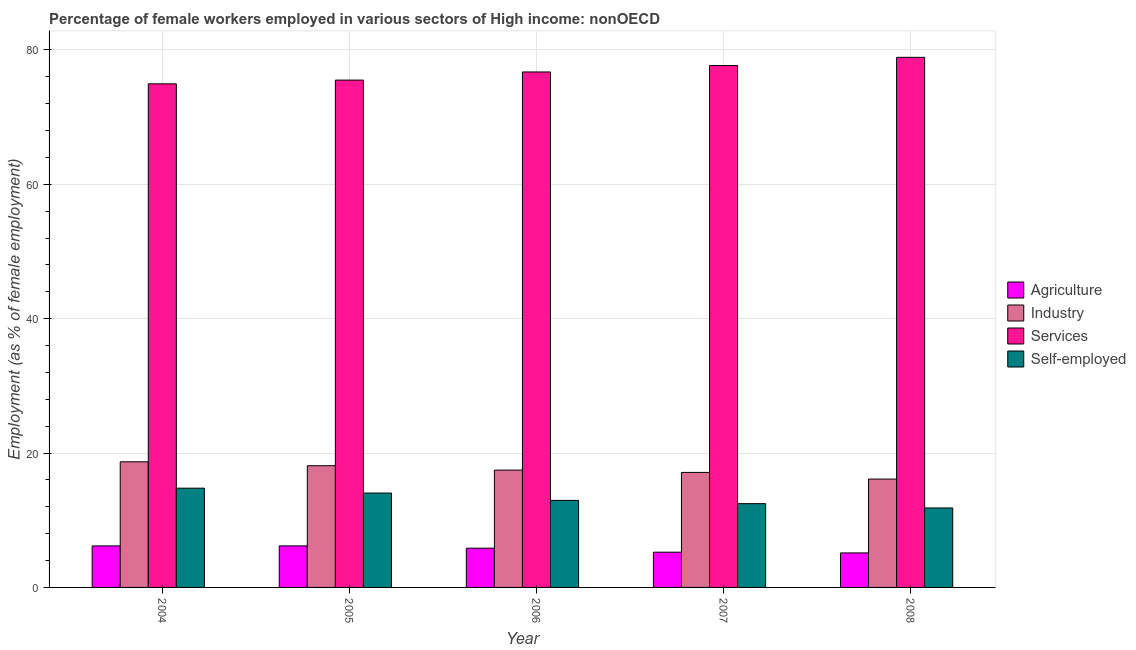How many different coloured bars are there?
Give a very brief answer. 4. In how many cases, is the number of bars for a given year not equal to the number of legend labels?
Give a very brief answer. 0. What is the percentage of female workers in agriculture in 2008?
Your answer should be very brief. 5.14. Across all years, what is the maximum percentage of female workers in agriculture?
Offer a very short reply. 6.18. Across all years, what is the minimum percentage of female workers in services?
Provide a short and direct response. 74.95. In which year was the percentage of female workers in services minimum?
Give a very brief answer. 2004. What is the total percentage of female workers in industry in the graph?
Give a very brief answer. 87.52. What is the difference between the percentage of female workers in industry in 2005 and that in 2007?
Offer a terse response. 1. What is the difference between the percentage of self employed female workers in 2005 and the percentage of female workers in services in 2007?
Ensure brevity in your answer.  1.58. What is the average percentage of self employed female workers per year?
Your response must be concise. 13.21. In how many years, is the percentage of female workers in industry greater than 32 %?
Your answer should be compact. 0. What is the ratio of the percentage of female workers in industry in 2006 to that in 2008?
Make the answer very short. 1.08. What is the difference between the highest and the second highest percentage of female workers in industry?
Your response must be concise. 0.58. What is the difference between the highest and the lowest percentage of female workers in agriculture?
Ensure brevity in your answer.  1.05. In how many years, is the percentage of female workers in services greater than the average percentage of female workers in services taken over all years?
Offer a very short reply. 2. Is the sum of the percentage of female workers in industry in 2007 and 2008 greater than the maximum percentage of female workers in agriculture across all years?
Provide a succinct answer. Yes. Is it the case that in every year, the sum of the percentage of female workers in agriculture and percentage of female workers in services is greater than the sum of percentage of female workers in industry and percentage of self employed female workers?
Make the answer very short. No. What does the 3rd bar from the left in 2004 represents?
Your answer should be compact. Services. What does the 3rd bar from the right in 2005 represents?
Give a very brief answer. Industry. How many bars are there?
Offer a very short reply. 20. How many years are there in the graph?
Offer a terse response. 5. Are the values on the major ticks of Y-axis written in scientific E-notation?
Ensure brevity in your answer.  No. Does the graph contain any zero values?
Your response must be concise. No. What is the title of the graph?
Keep it short and to the point. Percentage of female workers employed in various sectors of High income: nonOECD. What is the label or title of the X-axis?
Ensure brevity in your answer.  Year. What is the label or title of the Y-axis?
Your response must be concise. Employment (as % of female employment). What is the Employment (as % of female employment) in Agriculture in 2004?
Your answer should be compact. 6.18. What is the Employment (as % of female employment) of Industry in 2004?
Your answer should be very brief. 18.7. What is the Employment (as % of female employment) of Services in 2004?
Your answer should be very brief. 74.95. What is the Employment (as % of female employment) of Self-employed in 2004?
Give a very brief answer. 14.77. What is the Employment (as % of female employment) of Agriculture in 2005?
Make the answer very short. 6.18. What is the Employment (as % of female employment) in Industry in 2005?
Offer a very short reply. 18.11. What is the Employment (as % of female employment) of Services in 2005?
Offer a terse response. 75.51. What is the Employment (as % of female employment) in Self-employed in 2005?
Keep it short and to the point. 14.05. What is the Employment (as % of female employment) in Agriculture in 2006?
Offer a very short reply. 5.84. What is the Employment (as % of female employment) in Industry in 2006?
Offer a very short reply. 17.46. What is the Employment (as % of female employment) in Services in 2006?
Ensure brevity in your answer.  76.72. What is the Employment (as % of female employment) of Self-employed in 2006?
Your answer should be compact. 12.95. What is the Employment (as % of female employment) in Agriculture in 2007?
Your response must be concise. 5.24. What is the Employment (as % of female employment) of Industry in 2007?
Ensure brevity in your answer.  17.12. What is the Employment (as % of female employment) in Services in 2007?
Provide a succinct answer. 77.68. What is the Employment (as % of female employment) in Self-employed in 2007?
Offer a very short reply. 12.47. What is the Employment (as % of female employment) in Agriculture in 2008?
Offer a terse response. 5.14. What is the Employment (as % of female employment) of Industry in 2008?
Provide a short and direct response. 16.13. What is the Employment (as % of female employment) in Services in 2008?
Give a very brief answer. 78.9. What is the Employment (as % of female employment) in Self-employed in 2008?
Provide a short and direct response. 11.83. Across all years, what is the maximum Employment (as % of female employment) of Agriculture?
Provide a succinct answer. 6.18. Across all years, what is the maximum Employment (as % of female employment) of Industry?
Make the answer very short. 18.7. Across all years, what is the maximum Employment (as % of female employment) in Services?
Keep it short and to the point. 78.9. Across all years, what is the maximum Employment (as % of female employment) in Self-employed?
Your answer should be very brief. 14.77. Across all years, what is the minimum Employment (as % of female employment) of Agriculture?
Offer a terse response. 5.14. Across all years, what is the minimum Employment (as % of female employment) of Industry?
Make the answer very short. 16.13. Across all years, what is the minimum Employment (as % of female employment) in Services?
Your response must be concise. 74.95. Across all years, what is the minimum Employment (as % of female employment) in Self-employed?
Your answer should be very brief. 11.83. What is the total Employment (as % of female employment) in Agriculture in the graph?
Your response must be concise. 28.58. What is the total Employment (as % of female employment) of Industry in the graph?
Offer a terse response. 87.52. What is the total Employment (as % of female employment) of Services in the graph?
Provide a succinct answer. 383.76. What is the total Employment (as % of female employment) of Self-employed in the graph?
Provide a short and direct response. 66.06. What is the difference between the Employment (as % of female employment) in Agriculture in 2004 and that in 2005?
Ensure brevity in your answer.  -0.01. What is the difference between the Employment (as % of female employment) of Industry in 2004 and that in 2005?
Your answer should be very brief. 0.58. What is the difference between the Employment (as % of female employment) of Services in 2004 and that in 2005?
Ensure brevity in your answer.  -0.56. What is the difference between the Employment (as % of female employment) in Self-employed in 2004 and that in 2005?
Offer a terse response. 0.72. What is the difference between the Employment (as % of female employment) of Agriculture in 2004 and that in 2006?
Keep it short and to the point. 0.34. What is the difference between the Employment (as % of female employment) in Industry in 2004 and that in 2006?
Provide a succinct answer. 1.23. What is the difference between the Employment (as % of female employment) in Services in 2004 and that in 2006?
Give a very brief answer. -1.77. What is the difference between the Employment (as % of female employment) in Self-employed in 2004 and that in 2006?
Your response must be concise. 1.82. What is the difference between the Employment (as % of female employment) in Agriculture in 2004 and that in 2007?
Your response must be concise. 0.93. What is the difference between the Employment (as % of female employment) of Industry in 2004 and that in 2007?
Your response must be concise. 1.58. What is the difference between the Employment (as % of female employment) in Services in 2004 and that in 2007?
Give a very brief answer. -2.72. What is the difference between the Employment (as % of female employment) in Self-employed in 2004 and that in 2007?
Your answer should be very brief. 2.3. What is the difference between the Employment (as % of female employment) in Agriculture in 2004 and that in 2008?
Ensure brevity in your answer.  1.04. What is the difference between the Employment (as % of female employment) of Industry in 2004 and that in 2008?
Make the answer very short. 2.57. What is the difference between the Employment (as % of female employment) of Services in 2004 and that in 2008?
Keep it short and to the point. -3.94. What is the difference between the Employment (as % of female employment) of Self-employed in 2004 and that in 2008?
Offer a terse response. 2.94. What is the difference between the Employment (as % of female employment) in Agriculture in 2005 and that in 2006?
Make the answer very short. 0.34. What is the difference between the Employment (as % of female employment) of Industry in 2005 and that in 2006?
Provide a short and direct response. 0.65. What is the difference between the Employment (as % of female employment) of Services in 2005 and that in 2006?
Give a very brief answer. -1.21. What is the difference between the Employment (as % of female employment) of Self-employed in 2005 and that in 2006?
Your answer should be compact. 1.09. What is the difference between the Employment (as % of female employment) in Agriculture in 2005 and that in 2007?
Keep it short and to the point. 0.94. What is the difference between the Employment (as % of female employment) of Services in 2005 and that in 2007?
Offer a terse response. -2.17. What is the difference between the Employment (as % of female employment) of Self-employed in 2005 and that in 2007?
Provide a short and direct response. 1.58. What is the difference between the Employment (as % of female employment) of Agriculture in 2005 and that in 2008?
Provide a short and direct response. 1.05. What is the difference between the Employment (as % of female employment) in Industry in 2005 and that in 2008?
Provide a succinct answer. 1.99. What is the difference between the Employment (as % of female employment) in Services in 2005 and that in 2008?
Your answer should be compact. -3.39. What is the difference between the Employment (as % of female employment) of Self-employed in 2005 and that in 2008?
Give a very brief answer. 2.22. What is the difference between the Employment (as % of female employment) of Agriculture in 2006 and that in 2007?
Ensure brevity in your answer.  0.6. What is the difference between the Employment (as % of female employment) in Industry in 2006 and that in 2007?
Provide a succinct answer. 0.34. What is the difference between the Employment (as % of female employment) in Services in 2006 and that in 2007?
Keep it short and to the point. -0.96. What is the difference between the Employment (as % of female employment) of Self-employed in 2006 and that in 2007?
Provide a succinct answer. 0.48. What is the difference between the Employment (as % of female employment) of Agriculture in 2006 and that in 2008?
Offer a terse response. 0.7. What is the difference between the Employment (as % of female employment) of Industry in 2006 and that in 2008?
Your response must be concise. 1.34. What is the difference between the Employment (as % of female employment) of Services in 2006 and that in 2008?
Offer a very short reply. -2.18. What is the difference between the Employment (as % of female employment) in Self-employed in 2006 and that in 2008?
Provide a short and direct response. 1.13. What is the difference between the Employment (as % of female employment) in Agriculture in 2007 and that in 2008?
Give a very brief answer. 0.11. What is the difference between the Employment (as % of female employment) in Industry in 2007 and that in 2008?
Offer a terse response. 0.99. What is the difference between the Employment (as % of female employment) of Services in 2007 and that in 2008?
Provide a succinct answer. -1.22. What is the difference between the Employment (as % of female employment) of Self-employed in 2007 and that in 2008?
Ensure brevity in your answer.  0.64. What is the difference between the Employment (as % of female employment) of Agriculture in 2004 and the Employment (as % of female employment) of Industry in 2005?
Offer a terse response. -11.94. What is the difference between the Employment (as % of female employment) of Agriculture in 2004 and the Employment (as % of female employment) of Services in 2005?
Provide a short and direct response. -69.33. What is the difference between the Employment (as % of female employment) in Agriculture in 2004 and the Employment (as % of female employment) in Self-employed in 2005?
Offer a very short reply. -7.87. What is the difference between the Employment (as % of female employment) in Industry in 2004 and the Employment (as % of female employment) in Services in 2005?
Your response must be concise. -56.81. What is the difference between the Employment (as % of female employment) in Industry in 2004 and the Employment (as % of female employment) in Self-employed in 2005?
Make the answer very short. 4.65. What is the difference between the Employment (as % of female employment) in Services in 2004 and the Employment (as % of female employment) in Self-employed in 2005?
Offer a terse response. 60.91. What is the difference between the Employment (as % of female employment) of Agriculture in 2004 and the Employment (as % of female employment) of Industry in 2006?
Make the answer very short. -11.29. What is the difference between the Employment (as % of female employment) in Agriculture in 2004 and the Employment (as % of female employment) in Services in 2006?
Give a very brief answer. -70.54. What is the difference between the Employment (as % of female employment) of Agriculture in 2004 and the Employment (as % of female employment) of Self-employed in 2006?
Offer a terse response. -6.77. What is the difference between the Employment (as % of female employment) of Industry in 2004 and the Employment (as % of female employment) of Services in 2006?
Offer a terse response. -58.02. What is the difference between the Employment (as % of female employment) of Industry in 2004 and the Employment (as % of female employment) of Self-employed in 2006?
Your answer should be compact. 5.75. What is the difference between the Employment (as % of female employment) in Services in 2004 and the Employment (as % of female employment) in Self-employed in 2006?
Your answer should be very brief. 62. What is the difference between the Employment (as % of female employment) of Agriculture in 2004 and the Employment (as % of female employment) of Industry in 2007?
Keep it short and to the point. -10.94. What is the difference between the Employment (as % of female employment) of Agriculture in 2004 and the Employment (as % of female employment) of Services in 2007?
Ensure brevity in your answer.  -71.5. What is the difference between the Employment (as % of female employment) in Agriculture in 2004 and the Employment (as % of female employment) in Self-employed in 2007?
Ensure brevity in your answer.  -6.29. What is the difference between the Employment (as % of female employment) of Industry in 2004 and the Employment (as % of female employment) of Services in 2007?
Your answer should be very brief. -58.98. What is the difference between the Employment (as % of female employment) of Industry in 2004 and the Employment (as % of female employment) of Self-employed in 2007?
Ensure brevity in your answer.  6.23. What is the difference between the Employment (as % of female employment) in Services in 2004 and the Employment (as % of female employment) in Self-employed in 2007?
Your answer should be very brief. 62.49. What is the difference between the Employment (as % of female employment) of Agriculture in 2004 and the Employment (as % of female employment) of Industry in 2008?
Offer a very short reply. -9.95. What is the difference between the Employment (as % of female employment) of Agriculture in 2004 and the Employment (as % of female employment) of Services in 2008?
Your answer should be very brief. -72.72. What is the difference between the Employment (as % of female employment) of Agriculture in 2004 and the Employment (as % of female employment) of Self-employed in 2008?
Your response must be concise. -5.65. What is the difference between the Employment (as % of female employment) in Industry in 2004 and the Employment (as % of female employment) in Services in 2008?
Make the answer very short. -60.2. What is the difference between the Employment (as % of female employment) in Industry in 2004 and the Employment (as % of female employment) in Self-employed in 2008?
Make the answer very short. 6.87. What is the difference between the Employment (as % of female employment) of Services in 2004 and the Employment (as % of female employment) of Self-employed in 2008?
Give a very brief answer. 63.13. What is the difference between the Employment (as % of female employment) of Agriculture in 2005 and the Employment (as % of female employment) of Industry in 2006?
Your response must be concise. -11.28. What is the difference between the Employment (as % of female employment) of Agriculture in 2005 and the Employment (as % of female employment) of Services in 2006?
Keep it short and to the point. -70.54. What is the difference between the Employment (as % of female employment) of Agriculture in 2005 and the Employment (as % of female employment) of Self-employed in 2006?
Provide a short and direct response. -6.77. What is the difference between the Employment (as % of female employment) in Industry in 2005 and the Employment (as % of female employment) in Services in 2006?
Offer a very short reply. -58.61. What is the difference between the Employment (as % of female employment) of Industry in 2005 and the Employment (as % of female employment) of Self-employed in 2006?
Your answer should be very brief. 5.16. What is the difference between the Employment (as % of female employment) of Services in 2005 and the Employment (as % of female employment) of Self-employed in 2006?
Your answer should be very brief. 62.56. What is the difference between the Employment (as % of female employment) of Agriculture in 2005 and the Employment (as % of female employment) of Industry in 2007?
Give a very brief answer. -10.94. What is the difference between the Employment (as % of female employment) of Agriculture in 2005 and the Employment (as % of female employment) of Services in 2007?
Provide a short and direct response. -71.49. What is the difference between the Employment (as % of female employment) of Agriculture in 2005 and the Employment (as % of female employment) of Self-employed in 2007?
Provide a short and direct response. -6.28. What is the difference between the Employment (as % of female employment) of Industry in 2005 and the Employment (as % of female employment) of Services in 2007?
Provide a short and direct response. -59.56. What is the difference between the Employment (as % of female employment) of Industry in 2005 and the Employment (as % of female employment) of Self-employed in 2007?
Your response must be concise. 5.65. What is the difference between the Employment (as % of female employment) of Services in 2005 and the Employment (as % of female employment) of Self-employed in 2007?
Keep it short and to the point. 63.04. What is the difference between the Employment (as % of female employment) in Agriculture in 2005 and the Employment (as % of female employment) in Industry in 2008?
Ensure brevity in your answer.  -9.94. What is the difference between the Employment (as % of female employment) in Agriculture in 2005 and the Employment (as % of female employment) in Services in 2008?
Your answer should be compact. -72.71. What is the difference between the Employment (as % of female employment) in Agriculture in 2005 and the Employment (as % of female employment) in Self-employed in 2008?
Provide a succinct answer. -5.64. What is the difference between the Employment (as % of female employment) in Industry in 2005 and the Employment (as % of female employment) in Services in 2008?
Make the answer very short. -60.78. What is the difference between the Employment (as % of female employment) in Industry in 2005 and the Employment (as % of female employment) in Self-employed in 2008?
Offer a terse response. 6.29. What is the difference between the Employment (as % of female employment) of Services in 2005 and the Employment (as % of female employment) of Self-employed in 2008?
Keep it short and to the point. 63.68. What is the difference between the Employment (as % of female employment) in Agriculture in 2006 and the Employment (as % of female employment) in Industry in 2007?
Your answer should be very brief. -11.28. What is the difference between the Employment (as % of female employment) of Agriculture in 2006 and the Employment (as % of female employment) of Services in 2007?
Give a very brief answer. -71.84. What is the difference between the Employment (as % of female employment) in Agriculture in 2006 and the Employment (as % of female employment) in Self-employed in 2007?
Offer a very short reply. -6.63. What is the difference between the Employment (as % of female employment) of Industry in 2006 and the Employment (as % of female employment) of Services in 2007?
Make the answer very short. -60.21. What is the difference between the Employment (as % of female employment) in Industry in 2006 and the Employment (as % of female employment) in Self-employed in 2007?
Provide a succinct answer. 4.99. What is the difference between the Employment (as % of female employment) of Services in 2006 and the Employment (as % of female employment) of Self-employed in 2007?
Your answer should be very brief. 64.25. What is the difference between the Employment (as % of female employment) in Agriculture in 2006 and the Employment (as % of female employment) in Industry in 2008?
Provide a short and direct response. -10.29. What is the difference between the Employment (as % of female employment) in Agriculture in 2006 and the Employment (as % of female employment) in Services in 2008?
Your answer should be very brief. -73.06. What is the difference between the Employment (as % of female employment) in Agriculture in 2006 and the Employment (as % of female employment) in Self-employed in 2008?
Offer a very short reply. -5.99. What is the difference between the Employment (as % of female employment) in Industry in 2006 and the Employment (as % of female employment) in Services in 2008?
Keep it short and to the point. -61.44. What is the difference between the Employment (as % of female employment) in Industry in 2006 and the Employment (as % of female employment) in Self-employed in 2008?
Provide a short and direct response. 5.64. What is the difference between the Employment (as % of female employment) in Services in 2006 and the Employment (as % of female employment) in Self-employed in 2008?
Ensure brevity in your answer.  64.89. What is the difference between the Employment (as % of female employment) in Agriculture in 2007 and the Employment (as % of female employment) in Industry in 2008?
Provide a succinct answer. -10.88. What is the difference between the Employment (as % of female employment) of Agriculture in 2007 and the Employment (as % of female employment) of Services in 2008?
Provide a short and direct response. -73.65. What is the difference between the Employment (as % of female employment) of Agriculture in 2007 and the Employment (as % of female employment) of Self-employed in 2008?
Offer a very short reply. -6.58. What is the difference between the Employment (as % of female employment) in Industry in 2007 and the Employment (as % of female employment) in Services in 2008?
Your response must be concise. -61.78. What is the difference between the Employment (as % of female employment) of Industry in 2007 and the Employment (as % of female employment) of Self-employed in 2008?
Make the answer very short. 5.29. What is the difference between the Employment (as % of female employment) in Services in 2007 and the Employment (as % of female employment) in Self-employed in 2008?
Offer a terse response. 65.85. What is the average Employment (as % of female employment) in Agriculture per year?
Provide a succinct answer. 5.72. What is the average Employment (as % of female employment) of Industry per year?
Offer a very short reply. 17.5. What is the average Employment (as % of female employment) in Services per year?
Offer a terse response. 76.75. What is the average Employment (as % of female employment) in Self-employed per year?
Your response must be concise. 13.21. In the year 2004, what is the difference between the Employment (as % of female employment) of Agriculture and Employment (as % of female employment) of Industry?
Offer a very short reply. -12.52. In the year 2004, what is the difference between the Employment (as % of female employment) of Agriculture and Employment (as % of female employment) of Services?
Your answer should be very brief. -68.78. In the year 2004, what is the difference between the Employment (as % of female employment) of Agriculture and Employment (as % of female employment) of Self-employed?
Offer a very short reply. -8.59. In the year 2004, what is the difference between the Employment (as % of female employment) in Industry and Employment (as % of female employment) in Services?
Provide a succinct answer. -56.26. In the year 2004, what is the difference between the Employment (as % of female employment) in Industry and Employment (as % of female employment) in Self-employed?
Your response must be concise. 3.93. In the year 2004, what is the difference between the Employment (as % of female employment) of Services and Employment (as % of female employment) of Self-employed?
Your answer should be very brief. 60.18. In the year 2005, what is the difference between the Employment (as % of female employment) of Agriculture and Employment (as % of female employment) of Industry?
Ensure brevity in your answer.  -11.93. In the year 2005, what is the difference between the Employment (as % of female employment) in Agriculture and Employment (as % of female employment) in Services?
Your response must be concise. -69.33. In the year 2005, what is the difference between the Employment (as % of female employment) of Agriculture and Employment (as % of female employment) of Self-employed?
Offer a terse response. -7.86. In the year 2005, what is the difference between the Employment (as % of female employment) in Industry and Employment (as % of female employment) in Services?
Provide a succinct answer. -57.4. In the year 2005, what is the difference between the Employment (as % of female employment) in Industry and Employment (as % of female employment) in Self-employed?
Provide a short and direct response. 4.07. In the year 2005, what is the difference between the Employment (as % of female employment) of Services and Employment (as % of female employment) of Self-employed?
Your answer should be compact. 61.46. In the year 2006, what is the difference between the Employment (as % of female employment) in Agriculture and Employment (as % of female employment) in Industry?
Your response must be concise. -11.62. In the year 2006, what is the difference between the Employment (as % of female employment) in Agriculture and Employment (as % of female employment) in Services?
Provide a succinct answer. -70.88. In the year 2006, what is the difference between the Employment (as % of female employment) in Agriculture and Employment (as % of female employment) in Self-employed?
Give a very brief answer. -7.11. In the year 2006, what is the difference between the Employment (as % of female employment) in Industry and Employment (as % of female employment) in Services?
Give a very brief answer. -59.26. In the year 2006, what is the difference between the Employment (as % of female employment) of Industry and Employment (as % of female employment) of Self-employed?
Ensure brevity in your answer.  4.51. In the year 2006, what is the difference between the Employment (as % of female employment) in Services and Employment (as % of female employment) in Self-employed?
Your response must be concise. 63.77. In the year 2007, what is the difference between the Employment (as % of female employment) in Agriculture and Employment (as % of female employment) in Industry?
Give a very brief answer. -11.88. In the year 2007, what is the difference between the Employment (as % of female employment) of Agriculture and Employment (as % of female employment) of Services?
Your answer should be compact. -72.43. In the year 2007, what is the difference between the Employment (as % of female employment) of Agriculture and Employment (as % of female employment) of Self-employed?
Make the answer very short. -7.22. In the year 2007, what is the difference between the Employment (as % of female employment) of Industry and Employment (as % of female employment) of Services?
Your answer should be compact. -60.56. In the year 2007, what is the difference between the Employment (as % of female employment) of Industry and Employment (as % of female employment) of Self-employed?
Offer a terse response. 4.65. In the year 2007, what is the difference between the Employment (as % of female employment) of Services and Employment (as % of female employment) of Self-employed?
Give a very brief answer. 65.21. In the year 2008, what is the difference between the Employment (as % of female employment) in Agriculture and Employment (as % of female employment) in Industry?
Make the answer very short. -10.99. In the year 2008, what is the difference between the Employment (as % of female employment) in Agriculture and Employment (as % of female employment) in Services?
Keep it short and to the point. -73.76. In the year 2008, what is the difference between the Employment (as % of female employment) in Agriculture and Employment (as % of female employment) in Self-employed?
Make the answer very short. -6.69. In the year 2008, what is the difference between the Employment (as % of female employment) of Industry and Employment (as % of female employment) of Services?
Provide a succinct answer. -62.77. In the year 2008, what is the difference between the Employment (as % of female employment) in Industry and Employment (as % of female employment) in Self-employed?
Your response must be concise. 4.3. In the year 2008, what is the difference between the Employment (as % of female employment) in Services and Employment (as % of female employment) in Self-employed?
Offer a terse response. 67.07. What is the ratio of the Employment (as % of female employment) in Agriculture in 2004 to that in 2005?
Your answer should be very brief. 1. What is the ratio of the Employment (as % of female employment) of Industry in 2004 to that in 2005?
Ensure brevity in your answer.  1.03. What is the ratio of the Employment (as % of female employment) of Self-employed in 2004 to that in 2005?
Make the answer very short. 1.05. What is the ratio of the Employment (as % of female employment) in Agriculture in 2004 to that in 2006?
Make the answer very short. 1.06. What is the ratio of the Employment (as % of female employment) in Industry in 2004 to that in 2006?
Keep it short and to the point. 1.07. What is the ratio of the Employment (as % of female employment) in Self-employed in 2004 to that in 2006?
Keep it short and to the point. 1.14. What is the ratio of the Employment (as % of female employment) in Agriculture in 2004 to that in 2007?
Your answer should be very brief. 1.18. What is the ratio of the Employment (as % of female employment) of Industry in 2004 to that in 2007?
Your answer should be very brief. 1.09. What is the ratio of the Employment (as % of female employment) in Services in 2004 to that in 2007?
Keep it short and to the point. 0.96. What is the ratio of the Employment (as % of female employment) in Self-employed in 2004 to that in 2007?
Your answer should be very brief. 1.18. What is the ratio of the Employment (as % of female employment) in Agriculture in 2004 to that in 2008?
Keep it short and to the point. 1.2. What is the ratio of the Employment (as % of female employment) in Industry in 2004 to that in 2008?
Your answer should be very brief. 1.16. What is the ratio of the Employment (as % of female employment) in Services in 2004 to that in 2008?
Make the answer very short. 0.95. What is the ratio of the Employment (as % of female employment) of Self-employed in 2004 to that in 2008?
Provide a succinct answer. 1.25. What is the ratio of the Employment (as % of female employment) in Agriculture in 2005 to that in 2006?
Offer a terse response. 1.06. What is the ratio of the Employment (as % of female employment) in Industry in 2005 to that in 2006?
Make the answer very short. 1.04. What is the ratio of the Employment (as % of female employment) of Services in 2005 to that in 2006?
Your answer should be compact. 0.98. What is the ratio of the Employment (as % of female employment) of Self-employed in 2005 to that in 2006?
Keep it short and to the point. 1.08. What is the ratio of the Employment (as % of female employment) of Agriculture in 2005 to that in 2007?
Give a very brief answer. 1.18. What is the ratio of the Employment (as % of female employment) in Industry in 2005 to that in 2007?
Make the answer very short. 1.06. What is the ratio of the Employment (as % of female employment) in Services in 2005 to that in 2007?
Ensure brevity in your answer.  0.97. What is the ratio of the Employment (as % of female employment) in Self-employed in 2005 to that in 2007?
Your answer should be very brief. 1.13. What is the ratio of the Employment (as % of female employment) of Agriculture in 2005 to that in 2008?
Give a very brief answer. 1.2. What is the ratio of the Employment (as % of female employment) in Industry in 2005 to that in 2008?
Your answer should be very brief. 1.12. What is the ratio of the Employment (as % of female employment) of Services in 2005 to that in 2008?
Keep it short and to the point. 0.96. What is the ratio of the Employment (as % of female employment) in Self-employed in 2005 to that in 2008?
Your answer should be very brief. 1.19. What is the ratio of the Employment (as % of female employment) of Agriculture in 2006 to that in 2007?
Your answer should be compact. 1.11. What is the ratio of the Employment (as % of female employment) in Industry in 2006 to that in 2007?
Make the answer very short. 1.02. What is the ratio of the Employment (as % of female employment) of Self-employed in 2006 to that in 2007?
Provide a succinct answer. 1.04. What is the ratio of the Employment (as % of female employment) in Agriculture in 2006 to that in 2008?
Ensure brevity in your answer.  1.14. What is the ratio of the Employment (as % of female employment) of Industry in 2006 to that in 2008?
Provide a succinct answer. 1.08. What is the ratio of the Employment (as % of female employment) of Services in 2006 to that in 2008?
Offer a very short reply. 0.97. What is the ratio of the Employment (as % of female employment) of Self-employed in 2006 to that in 2008?
Give a very brief answer. 1.1. What is the ratio of the Employment (as % of female employment) in Agriculture in 2007 to that in 2008?
Your answer should be compact. 1.02. What is the ratio of the Employment (as % of female employment) of Industry in 2007 to that in 2008?
Provide a succinct answer. 1.06. What is the ratio of the Employment (as % of female employment) in Services in 2007 to that in 2008?
Your response must be concise. 0.98. What is the ratio of the Employment (as % of female employment) of Self-employed in 2007 to that in 2008?
Ensure brevity in your answer.  1.05. What is the difference between the highest and the second highest Employment (as % of female employment) in Agriculture?
Your response must be concise. 0.01. What is the difference between the highest and the second highest Employment (as % of female employment) of Industry?
Offer a very short reply. 0.58. What is the difference between the highest and the second highest Employment (as % of female employment) in Services?
Keep it short and to the point. 1.22. What is the difference between the highest and the second highest Employment (as % of female employment) of Self-employed?
Your response must be concise. 0.72. What is the difference between the highest and the lowest Employment (as % of female employment) in Agriculture?
Provide a succinct answer. 1.05. What is the difference between the highest and the lowest Employment (as % of female employment) of Industry?
Your answer should be very brief. 2.57. What is the difference between the highest and the lowest Employment (as % of female employment) of Services?
Make the answer very short. 3.94. What is the difference between the highest and the lowest Employment (as % of female employment) of Self-employed?
Offer a terse response. 2.94. 